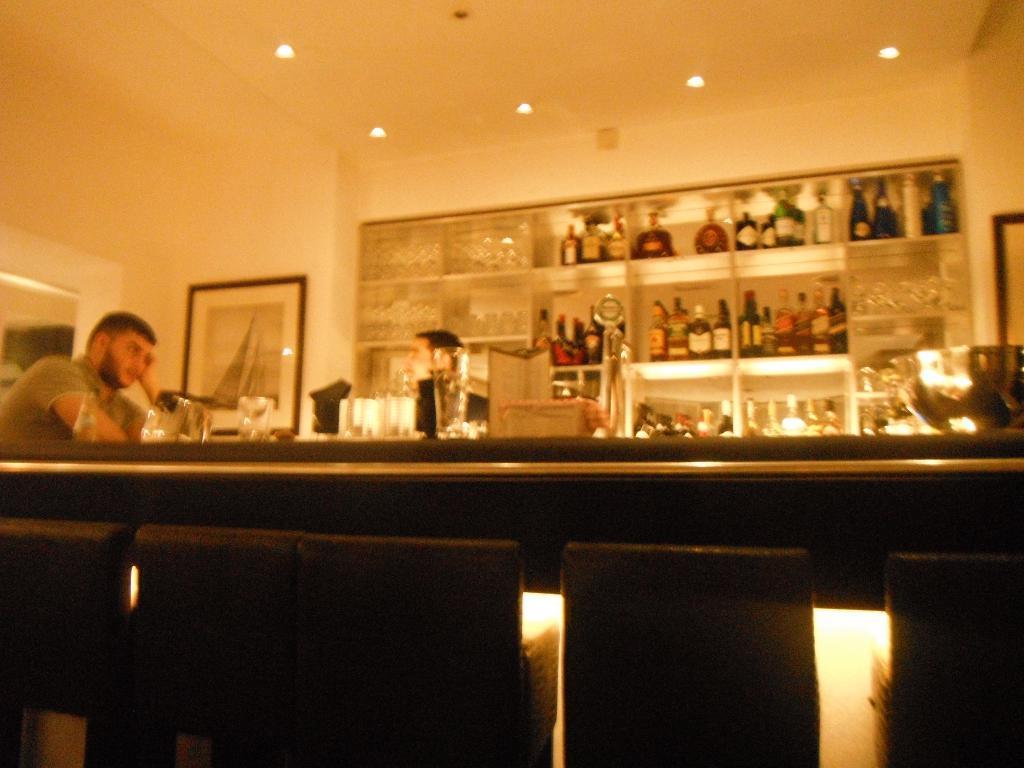Could you give a brief overview of what you see in this image? In the image we can see there are people wearing clothes. Here we can see shelves, on the shelves there are many bottles of different sizes. Here we can see frame stick to the wall and there are lights. 